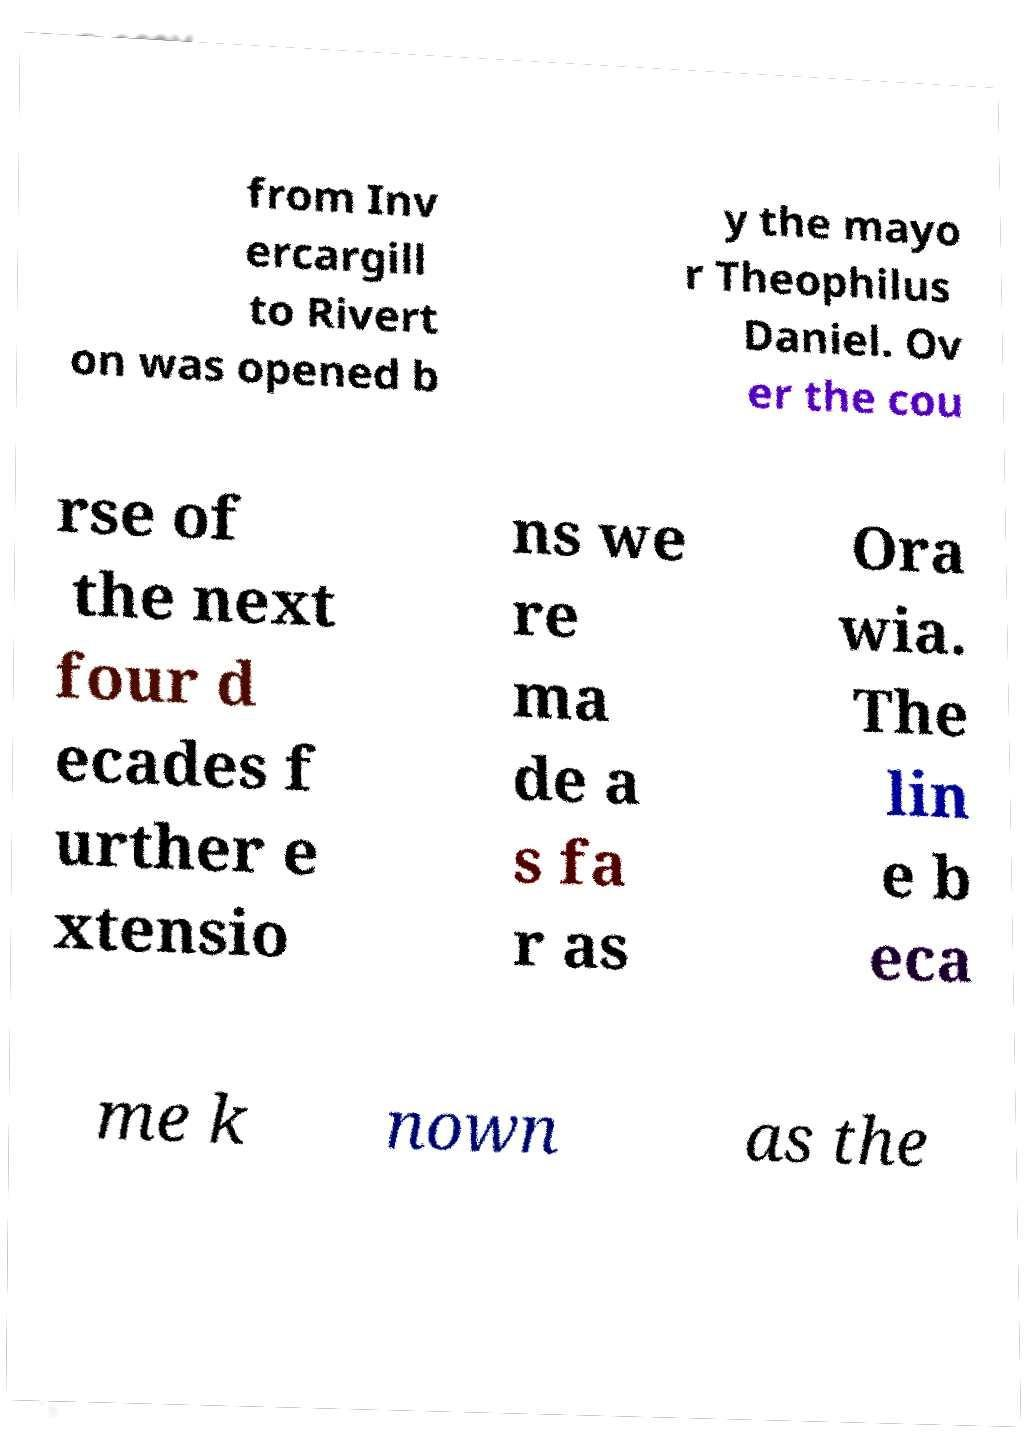There's text embedded in this image that I need extracted. Can you transcribe it verbatim? from Inv ercargill to Rivert on was opened b y the mayo r Theophilus Daniel. Ov er the cou rse of the next four d ecades f urther e xtensio ns we re ma de a s fa r as Ora wia. The lin e b eca me k nown as the 